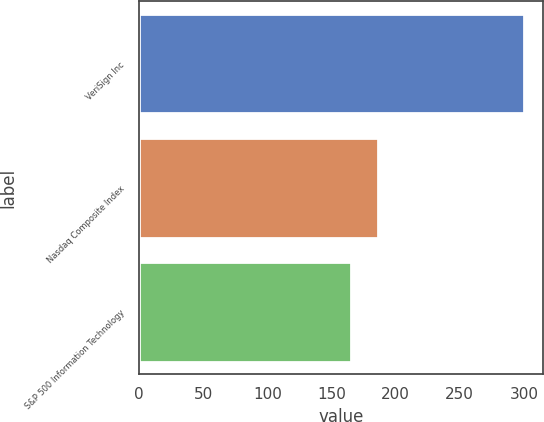<chart> <loc_0><loc_0><loc_500><loc_500><bar_chart><fcel>VeriSign Inc<fcel>Nasdaq Composite Index<fcel>S&P 500 Information Technology<nl><fcel>300<fcel>186<fcel>165<nl></chart> 